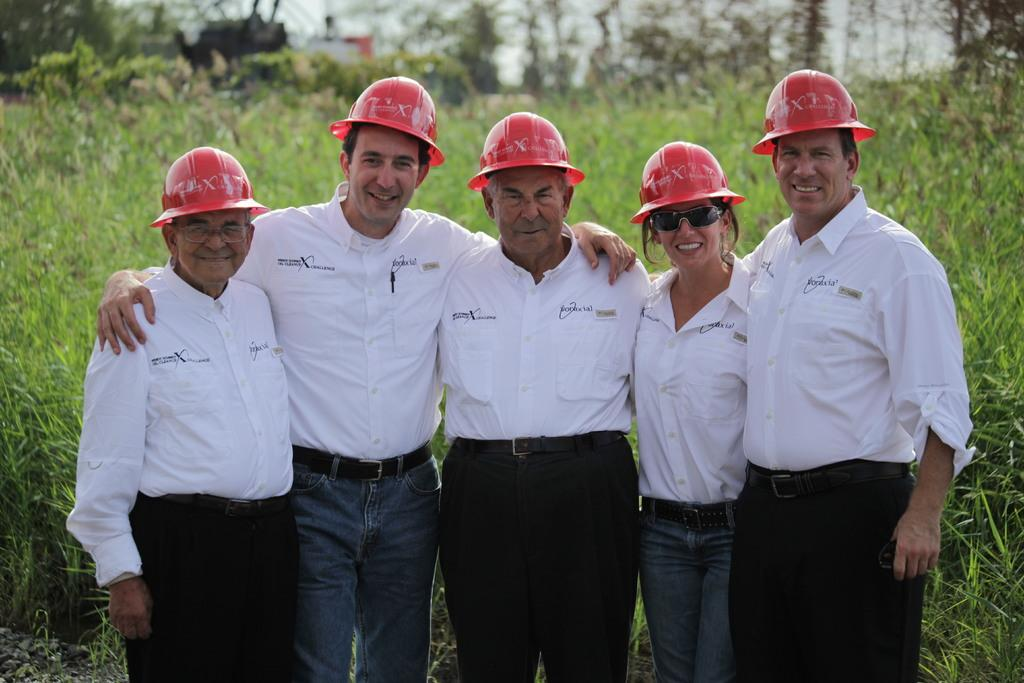What are the persons in the image doing? The persons in the image are standing on the ground. What can be seen in the background of the image? The sky, trees, and grass are visible in the background of the image. What type of collar can be seen on the jeans in the image? There are no jeans or collars present in the image. What day of the week is depicted in the image? The image does not depict a specific day of the week; it only shows persons standing on the ground and the background. 